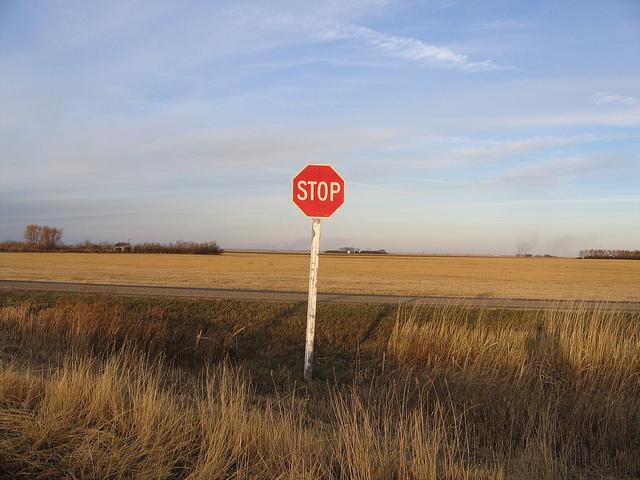What do cars do here?
Be succinct. Stop. Is there a lot of traffic?
Answer briefly. No. Is this sign bent?
Concise answer only. No. What is a car expected to do when it encounters this sign?
Answer briefly. Stop. 